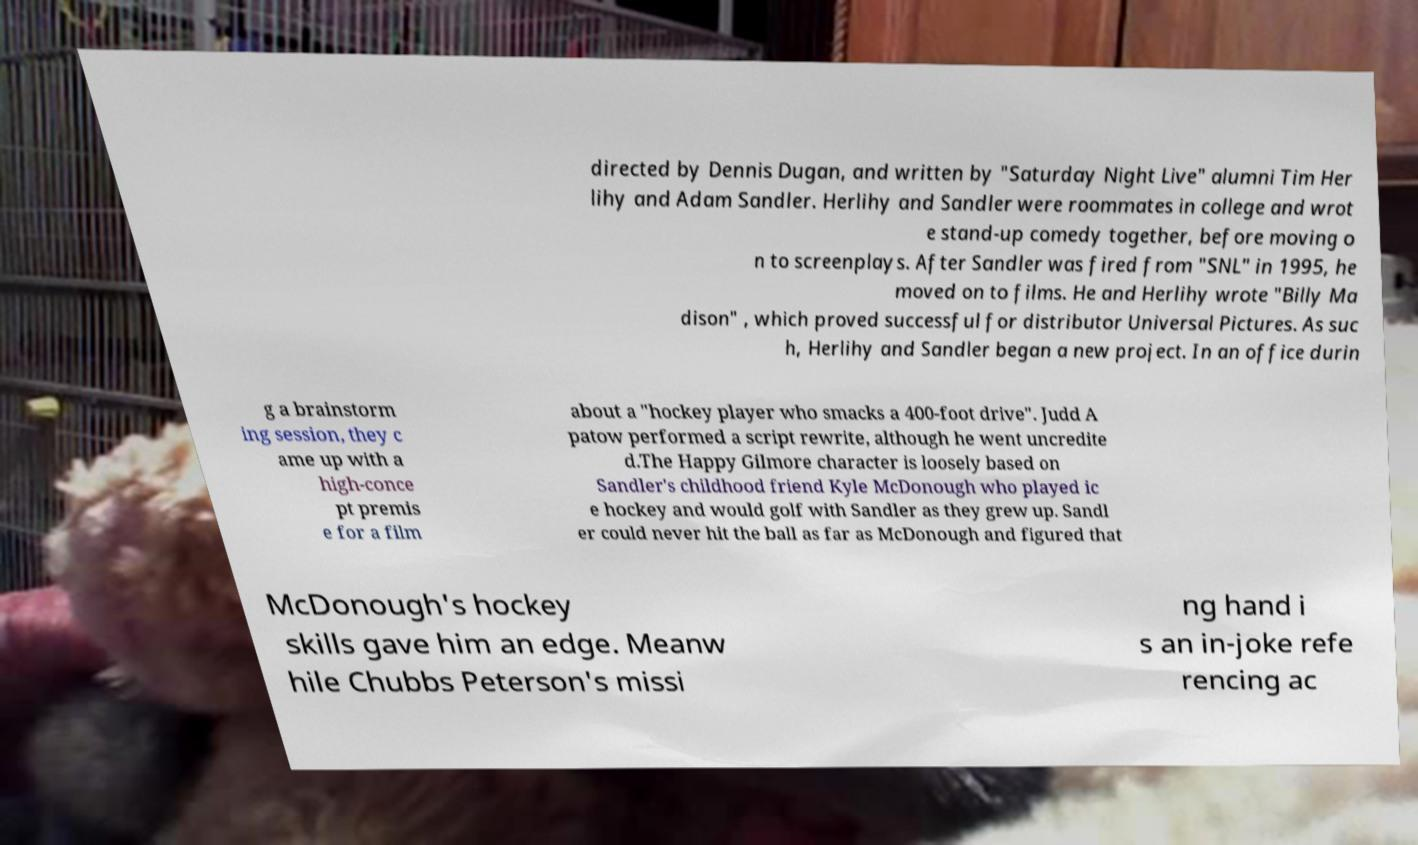Please identify and transcribe the text found in this image. directed by Dennis Dugan, and written by "Saturday Night Live" alumni Tim Her lihy and Adam Sandler. Herlihy and Sandler were roommates in college and wrot e stand-up comedy together, before moving o n to screenplays. After Sandler was fired from "SNL" in 1995, he moved on to films. He and Herlihy wrote "Billy Ma dison" , which proved successful for distributor Universal Pictures. As suc h, Herlihy and Sandler began a new project. In an office durin g a brainstorm ing session, they c ame up with a high-conce pt premis e for a film about a "hockey player who smacks a 400-foot drive". Judd A patow performed a script rewrite, although he went uncredite d.The Happy Gilmore character is loosely based on Sandler's childhood friend Kyle McDonough who played ic e hockey and would golf with Sandler as they grew up. Sandl er could never hit the ball as far as McDonough and figured that McDonough's hockey skills gave him an edge. Meanw hile Chubbs Peterson's missi ng hand i s an in-joke refe rencing ac 